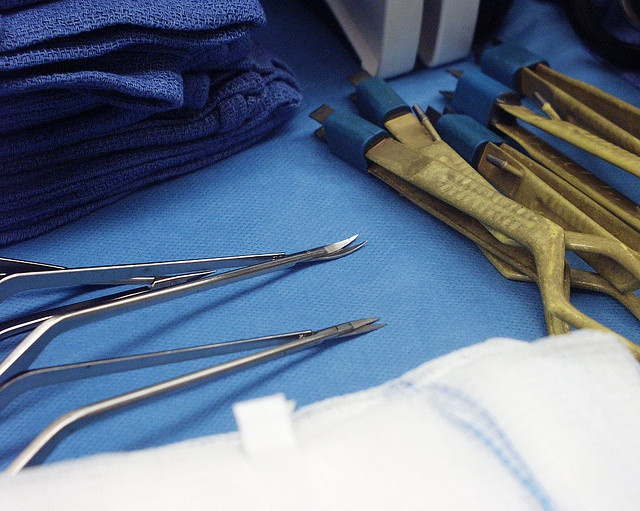Describe the objects in this image and their specific colors. I can see scissors in black, blue, gray, and white tones and scissors in black, blue, and gray tones in this image. 